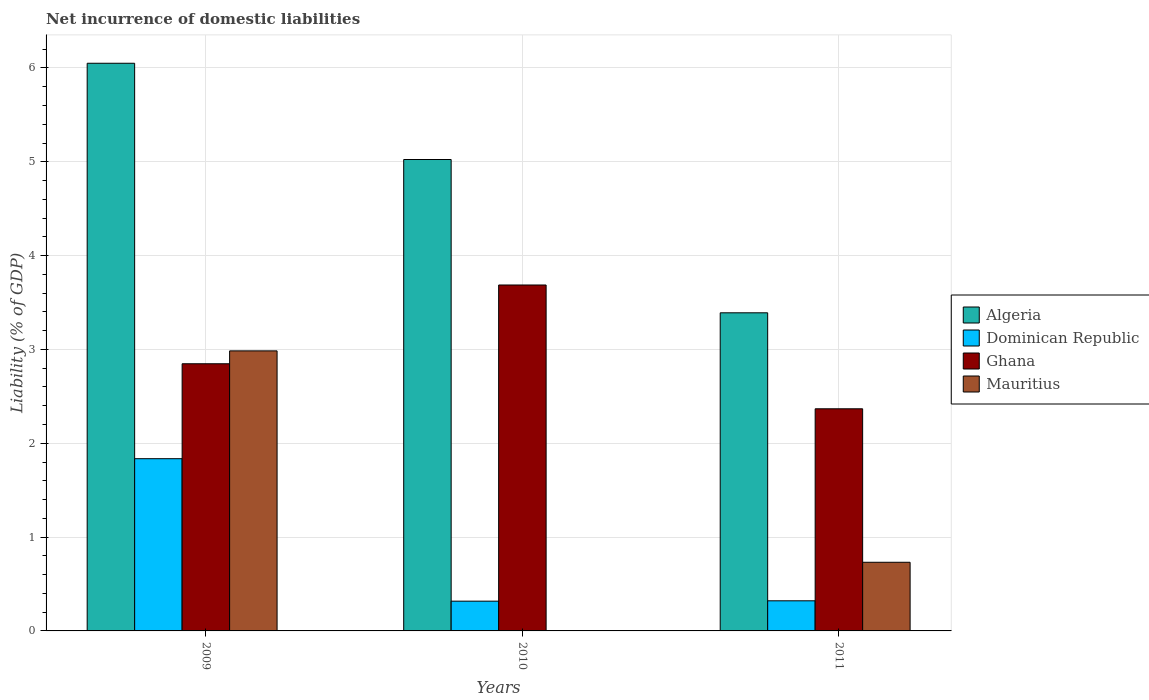How many different coloured bars are there?
Ensure brevity in your answer.  4. Are the number of bars per tick equal to the number of legend labels?
Your answer should be compact. No. In how many cases, is the number of bars for a given year not equal to the number of legend labels?
Provide a short and direct response. 1. What is the net incurrence of domestic liabilities in Mauritius in 2010?
Your answer should be very brief. 0. Across all years, what is the maximum net incurrence of domestic liabilities in Mauritius?
Ensure brevity in your answer.  2.98. In which year was the net incurrence of domestic liabilities in Algeria maximum?
Ensure brevity in your answer.  2009. What is the total net incurrence of domestic liabilities in Ghana in the graph?
Offer a very short reply. 8.9. What is the difference between the net incurrence of domestic liabilities in Dominican Republic in 2009 and that in 2010?
Offer a very short reply. 1.52. What is the difference between the net incurrence of domestic liabilities in Ghana in 2010 and the net incurrence of domestic liabilities in Algeria in 2009?
Ensure brevity in your answer.  -2.36. What is the average net incurrence of domestic liabilities in Mauritius per year?
Give a very brief answer. 1.24. In the year 2011, what is the difference between the net incurrence of domestic liabilities in Dominican Republic and net incurrence of domestic liabilities in Ghana?
Provide a short and direct response. -2.05. What is the ratio of the net incurrence of domestic liabilities in Dominican Republic in 2009 to that in 2010?
Ensure brevity in your answer.  5.79. Is the net incurrence of domestic liabilities in Ghana in 2010 less than that in 2011?
Keep it short and to the point. No. What is the difference between the highest and the second highest net incurrence of domestic liabilities in Dominican Republic?
Make the answer very short. 1.51. What is the difference between the highest and the lowest net incurrence of domestic liabilities in Mauritius?
Keep it short and to the point. 2.98. Is the sum of the net incurrence of domestic liabilities in Algeria in 2009 and 2011 greater than the maximum net incurrence of domestic liabilities in Dominican Republic across all years?
Provide a succinct answer. Yes. Is it the case that in every year, the sum of the net incurrence of domestic liabilities in Dominican Republic and net incurrence of domestic liabilities in Ghana is greater than the sum of net incurrence of domestic liabilities in Mauritius and net incurrence of domestic liabilities in Algeria?
Your response must be concise. No. Is it the case that in every year, the sum of the net incurrence of domestic liabilities in Ghana and net incurrence of domestic liabilities in Algeria is greater than the net incurrence of domestic liabilities in Dominican Republic?
Your answer should be compact. Yes. How many years are there in the graph?
Ensure brevity in your answer.  3. What is the difference between two consecutive major ticks on the Y-axis?
Your answer should be compact. 1. Does the graph contain grids?
Offer a very short reply. Yes. Where does the legend appear in the graph?
Provide a short and direct response. Center right. What is the title of the graph?
Provide a short and direct response. Net incurrence of domestic liabilities. Does "Cuba" appear as one of the legend labels in the graph?
Your answer should be very brief. No. What is the label or title of the Y-axis?
Provide a short and direct response. Liability (% of GDP). What is the Liability (% of GDP) of Algeria in 2009?
Your answer should be compact. 6.05. What is the Liability (% of GDP) in Dominican Republic in 2009?
Give a very brief answer. 1.84. What is the Liability (% of GDP) of Ghana in 2009?
Your response must be concise. 2.85. What is the Liability (% of GDP) of Mauritius in 2009?
Make the answer very short. 2.98. What is the Liability (% of GDP) in Algeria in 2010?
Provide a short and direct response. 5.02. What is the Liability (% of GDP) of Dominican Republic in 2010?
Offer a terse response. 0.32. What is the Liability (% of GDP) in Ghana in 2010?
Give a very brief answer. 3.69. What is the Liability (% of GDP) in Mauritius in 2010?
Your response must be concise. 0. What is the Liability (% of GDP) of Algeria in 2011?
Your answer should be very brief. 3.39. What is the Liability (% of GDP) of Dominican Republic in 2011?
Give a very brief answer. 0.32. What is the Liability (% of GDP) in Ghana in 2011?
Your answer should be very brief. 2.37. What is the Liability (% of GDP) in Mauritius in 2011?
Offer a very short reply. 0.73. Across all years, what is the maximum Liability (% of GDP) in Algeria?
Your answer should be compact. 6.05. Across all years, what is the maximum Liability (% of GDP) in Dominican Republic?
Provide a short and direct response. 1.84. Across all years, what is the maximum Liability (% of GDP) in Ghana?
Your answer should be very brief. 3.69. Across all years, what is the maximum Liability (% of GDP) in Mauritius?
Make the answer very short. 2.98. Across all years, what is the minimum Liability (% of GDP) in Algeria?
Your answer should be compact. 3.39. Across all years, what is the minimum Liability (% of GDP) of Dominican Republic?
Your response must be concise. 0.32. Across all years, what is the minimum Liability (% of GDP) of Ghana?
Give a very brief answer. 2.37. Across all years, what is the minimum Liability (% of GDP) in Mauritius?
Keep it short and to the point. 0. What is the total Liability (% of GDP) in Algeria in the graph?
Offer a very short reply. 14.47. What is the total Liability (% of GDP) of Dominican Republic in the graph?
Make the answer very short. 2.47. What is the total Liability (% of GDP) in Ghana in the graph?
Make the answer very short. 8.9. What is the total Liability (% of GDP) in Mauritius in the graph?
Your answer should be compact. 3.72. What is the difference between the Liability (% of GDP) of Algeria in 2009 and that in 2010?
Give a very brief answer. 1.03. What is the difference between the Liability (% of GDP) of Dominican Republic in 2009 and that in 2010?
Provide a succinct answer. 1.52. What is the difference between the Liability (% of GDP) of Ghana in 2009 and that in 2010?
Provide a short and direct response. -0.84. What is the difference between the Liability (% of GDP) in Algeria in 2009 and that in 2011?
Make the answer very short. 2.66. What is the difference between the Liability (% of GDP) of Dominican Republic in 2009 and that in 2011?
Ensure brevity in your answer.  1.51. What is the difference between the Liability (% of GDP) of Ghana in 2009 and that in 2011?
Your answer should be compact. 0.48. What is the difference between the Liability (% of GDP) of Mauritius in 2009 and that in 2011?
Offer a very short reply. 2.25. What is the difference between the Liability (% of GDP) of Algeria in 2010 and that in 2011?
Provide a short and direct response. 1.63. What is the difference between the Liability (% of GDP) in Dominican Republic in 2010 and that in 2011?
Make the answer very short. -0. What is the difference between the Liability (% of GDP) in Ghana in 2010 and that in 2011?
Keep it short and to the point. 1.32. What is the difference between the Liability (% of GDP) in Algeria in 2009 and the Liability (% of GDP) in Dominican Republic in 2010?
Give a very brief answer. 5.73. What is the difference between the Liability (% of GDP) of Algeria in 2009 and the Liability (% of GDP) of Ghana in 2010?
Provide a succinct answer. 2.36. What is the difference between the Liability (% of GDP) in Dominican Republic in 2009 and the Liability (% of GDP) in Ghana in 2010?
Make the answer very short. -1.85. What is the difference between the Liability (% of GDP) in Algeria in 2009 and the Liability (% of GDP) in Dominican Republic in 2011?
Ensure brevity in your answer.  5.73. What is the difference between the Liability (% of GDP) in Algeria in 2009 and the Liability (% of GDP) in Ghana in 2011?
Keep it short and to the point. 3.68. What is the difference between the Liability (% of GDP) of Algeria in 2009 and the Liability (% of GDP) of Mauritius in 2011?
Give a very brief answer. 5.32. What is the difference between the Liability (% of GDP) in Dominican Republic in 2009 and the Liability (% of GDP) in Ghana in 2011?
Your answer should be compact. -0.53. What is the difference between the Liability (% of GDP) in Dominican Republic in 2009 and the Liability (% of GDP) in Mauritius in 2011?
Offer a terse response. 1.1. What is the difference between the Liability (% of GDP) of Ghana in 2009 and the Liability (% of GDP) of Mauritius in 2011?
Provide a short and direct response. 2.12. What is the difference between the Liability (% of GDP) in Algeria in 2010 and the Liability (% of GDP) in Dominican Republic in 2011?
Offer a very short reply. 4.7. What is the difference between the Liability (% of GDP) of Algeria in 2010 and the Liability (% of GDP) of Ghana in 2011?
Offer a terse response. 2.66. What is the difference between the Liability (% of GDP) of Algeria in 2010 and the Liability (% of GDP) of Mauritius in 2011?
Keep it short and to the point. 4.29. What is the difference between the Liability (% of GDP) in Dominican Republic in 2010 and the Liability (% of GDP) in Ghana in 2011?
Your answer should be compact. -2.05. What is the difference between the Liability (% of GDP) of Dominican Republic in 2010 and the Liability (% of GDP) of Mauritius in 2011?
Your response must be concise. -0.41. What is the difference between the Liability (% of GDP) of Ghana in 2010 and the Liability (% of GDP) of Mauritius in 2011?
Offer a very short reply. 2.96. What is the average Liability (% of GDP) in Algeria per year?
Make the answer very short. 4.82. What is the average Liability (% of GDP) in Dominican Republic per year?
Provide a short and direct response. 0.82. What is the average Liability (% of GDP) in Ghana per year?
Ensure brevity in your answer.  2.97. What is the average Liability (% of GDP) in Mauritius per year?
Make the answer very short. 1.24. In the year 2009, what is the difference between the Liability (% of GDP) of Algeria and Liability (% of GDP) of Dominican Republic?
Ensure brevity in your answer.  4.21. In the year 2009, what is the difference between the Liability (% of GDP) of Algeria and Liability (% of GDP) of Ghana?
Offer a very short reply. 3.2. In the year 2009, what is the difference between the Liability (% of GDP) of Algeria and Liability (% of GDP) of Mauritius?
Ensure brevity in your answer.  3.07. In the year 2009, what is the difference between the Liability (% of GDP) in Dominican Republic and Liability (% of GDP) in Ghana?
Your answer should be compact. -1.01. In the year 2009, what is the difference between the Liability (% of GDP) of Dominican Republic and Liability (% of GDP) of Mauritius?
Offer a very short reply. -1.15. In the year 2009, what is the difference between the Liability (% of GDP) in Ghana and Liability (% of GDP) in Mauritius?
Ensure brevity in your answer.  -0.14. In the year 2010, what is the difference between the Liability (% of GDP) of Algeria and Liability (% of GDP) of Dominican Republic?
Ensure brevity in your answer.  4.71. In the year 2010, what is the difference between the Liability (% of GDP) of Algeria and Liability (% of GDP) of Ghana?
Keep it short and to the point. 1.34. In the year 2010, what is the difference between the Liability (% of GDP) in Dominican Republic and Liability (% of GDP) in Ghana?
Provide a succinct answer. -3.37. In the year 2011, what is the difference between the Liability (% of GDP) in Algeria and Liability (% of GDP) in Dominican Republic?
Provide a short and direct response. 3.07. In the year 2011, what is the difference between the Liability (% of GDP) in Algeria and Liability (% of GDP) in Mauritius?
Provide a short and direct response. 2.66. In the year 2011, what is the difference between the Liability (% of GDP) in Dominican Republic and Liability (% of GDP) in Ghana?
Offer a very short reply. -2.05. In the year 2011, what is the difference between the Liability (% of GDP) in Dominican Republic and Liability (% of GDP) in Mauritius?
Ensure brevity in your answer.  -0.41. In the year 2011, what is the difference between the Liability (% of GDP) of Ghana and Liability (% of GDP) of Mauritius?
Make the answer very short. 1.64. What is the ratio of the Liability (% of GDP) of Algeria in 2009 to that in 2010?
Keep it short and to the point. 1.2. What is the ratio of the Liability (% of GDP) in Dominican Republic in 2009 to that in 2010?
Your answer should be very brief. 5.79. What is the ratio of the Liability (% of GDP) of Ghana in 2009 to that in 2010?
Offer a very short reply. 0.77. What is the ratio of the Liability (% of GDP) of Algeria in 2009 to that in 2011?
Ensure brevity in your answer.  1.78. What is the ratio of the Liability (% of GDP) of Dominican Republic in 2009 to that in 2011?
Give a very brief answer. 5.72. What is the ratio of the Liability (% of GDP) of Ghana in 2009 to that in 2011?
Provide a short and direct response. 1.2. What is the ratio of the Liability (% of GDP) of Mauritius in 2009 to that in 2011?
Your response must be concise. 4.08. What is the ratio of the Liability (% of GDP) in Algeria in 2010 to that in 2011?
Your answer should be compact. 1.48. What is the ratio of the Liability (% of GDP) of Ghana in 2010 to that in 2011?
Ensure brevity in your answer.  1.56. What is the difference between the highest and the second highest Liability (% of GDP) in Algeria?
Your answer should be compact. 1.03. What is the difference between the highest and the second highest Liability (% of GDP) of Dominican Republic?
Offer a terse response. 1.51. What is the difference between the highest and the second highest Liability (% of GDP) of Ghana?
Your answer should be compact. 0.84. What is the difference between the highest and the lowest Liability (% of GDP) in Algeria?
Offer a very short reply. 2.66. What is the difference between the highest and the lowest Liability (% of GDP) of Dominican Republic?
Your answer should be very brief. 1.52. What is the difference between the highest and the lowest Liability (% of GDP) of Ghana?
Give a very brief answer. 1.32. What is the difference between the highest and the lowest Liability (% of GDP) of Mauritius?
Provide a succinct answer. 2.98. 